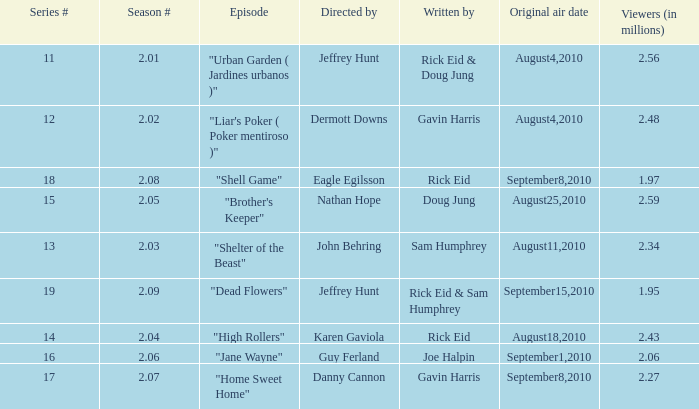What is the amount of viewers if the series number is 14? 2.43. 